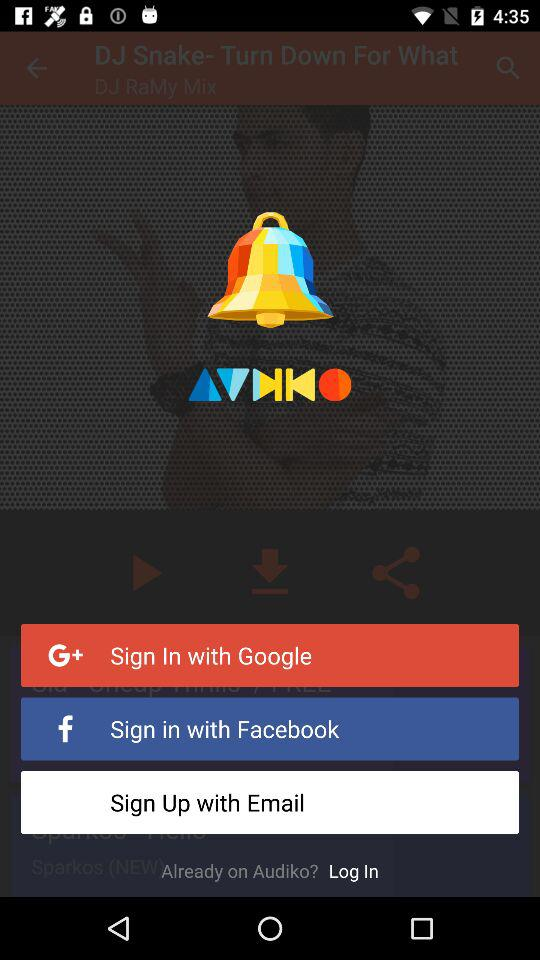How can we sign in? You can sign in with "Google", "Facebook" and "Email". 